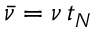Convert formula to latex. <formula><loc_0><loc_0><loc_500><loc_500>\ B a r { \nu } = \nu \, t _ { N }</formula> 